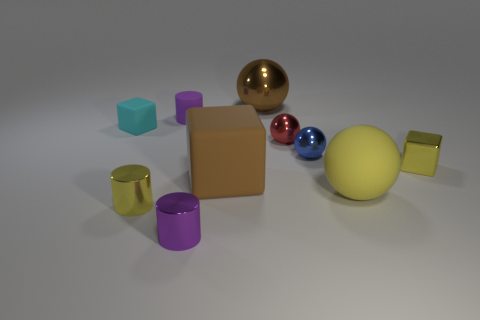Subtract 1 cubes. How many cubes are left? 2 Subtract all cyan balls. Subtract all brown cylinders. How many balls are left? 4 Subtract all cubes. How many objects are left? 7 Subtract all big brown metal balls. Subtract all metallic things. How many objects are left? 3 Add 4 big brown metal things. How many big brown metal things are left? 5 Add 1 tiny purple metal cylinders. How many tiny purple metal cylinders exist? 2 Subtract 0 gray blocks. How many objects are left? 10 